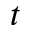Convert formula to latex. <formula><loc_0><loc_0><loc_500><loc_500>t</formula> 